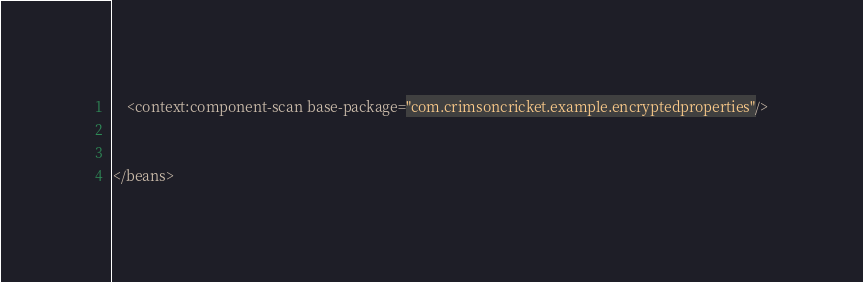<code> <loc_0><loc_0><loc_500><loc_500><_XML_>

	<context:component-scan base-package="com.crimsoncricket.example.encryptedproperties"/>


</beans></code> 